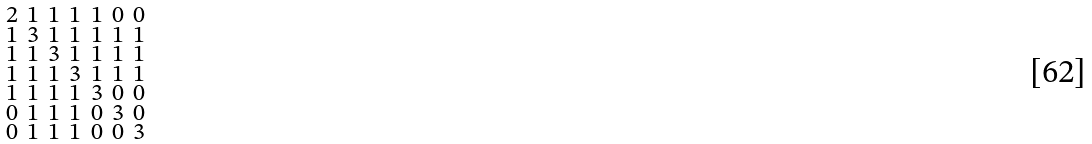<formula> <loc_0><loc_0><loc_500><loc_500>\begin{smallmatrix} 2 & 1 & 1 & 1 & 1 & 0 & 0 \\ 1 & 3 & 1 & 1 & 1 & 1 & 1 \\ 1 & 1 & 3 & 1 & 1 & 1 & 1 \\ 1 & 1 & 1 & 3 & 1 & 1 & 1 \\ 1 & 1 & 1 & 1 & 3 & 0 & 0 \\ 0 & 1 & 1 & 1 & 0 & 3 & 0 \\ 0 & 1 & 1 & 1 & 0 & 0 & 3 \end{smallmatrix}</formula> 